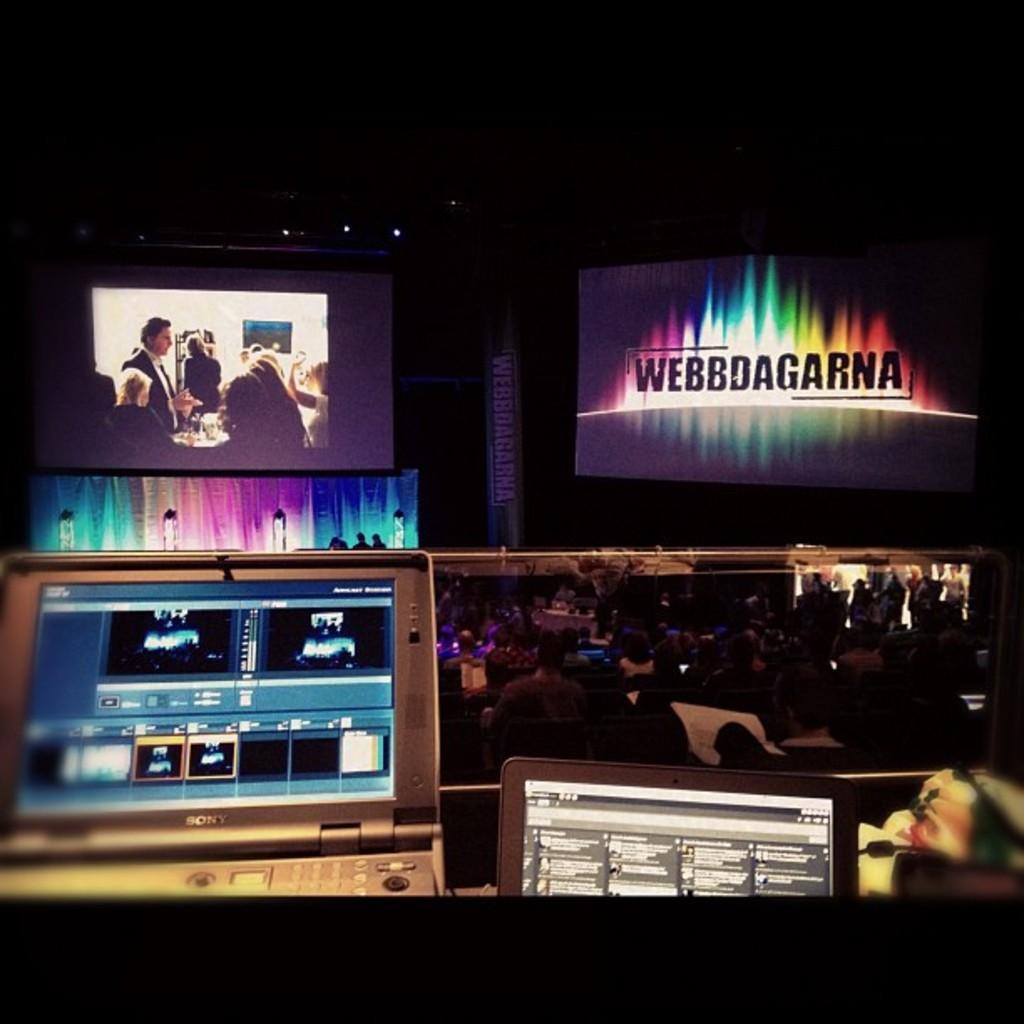Please provide a concise description of this image. In this picture we can see laptops, screens, lights, banner, some objects and a group of people and in the background it is dark. 